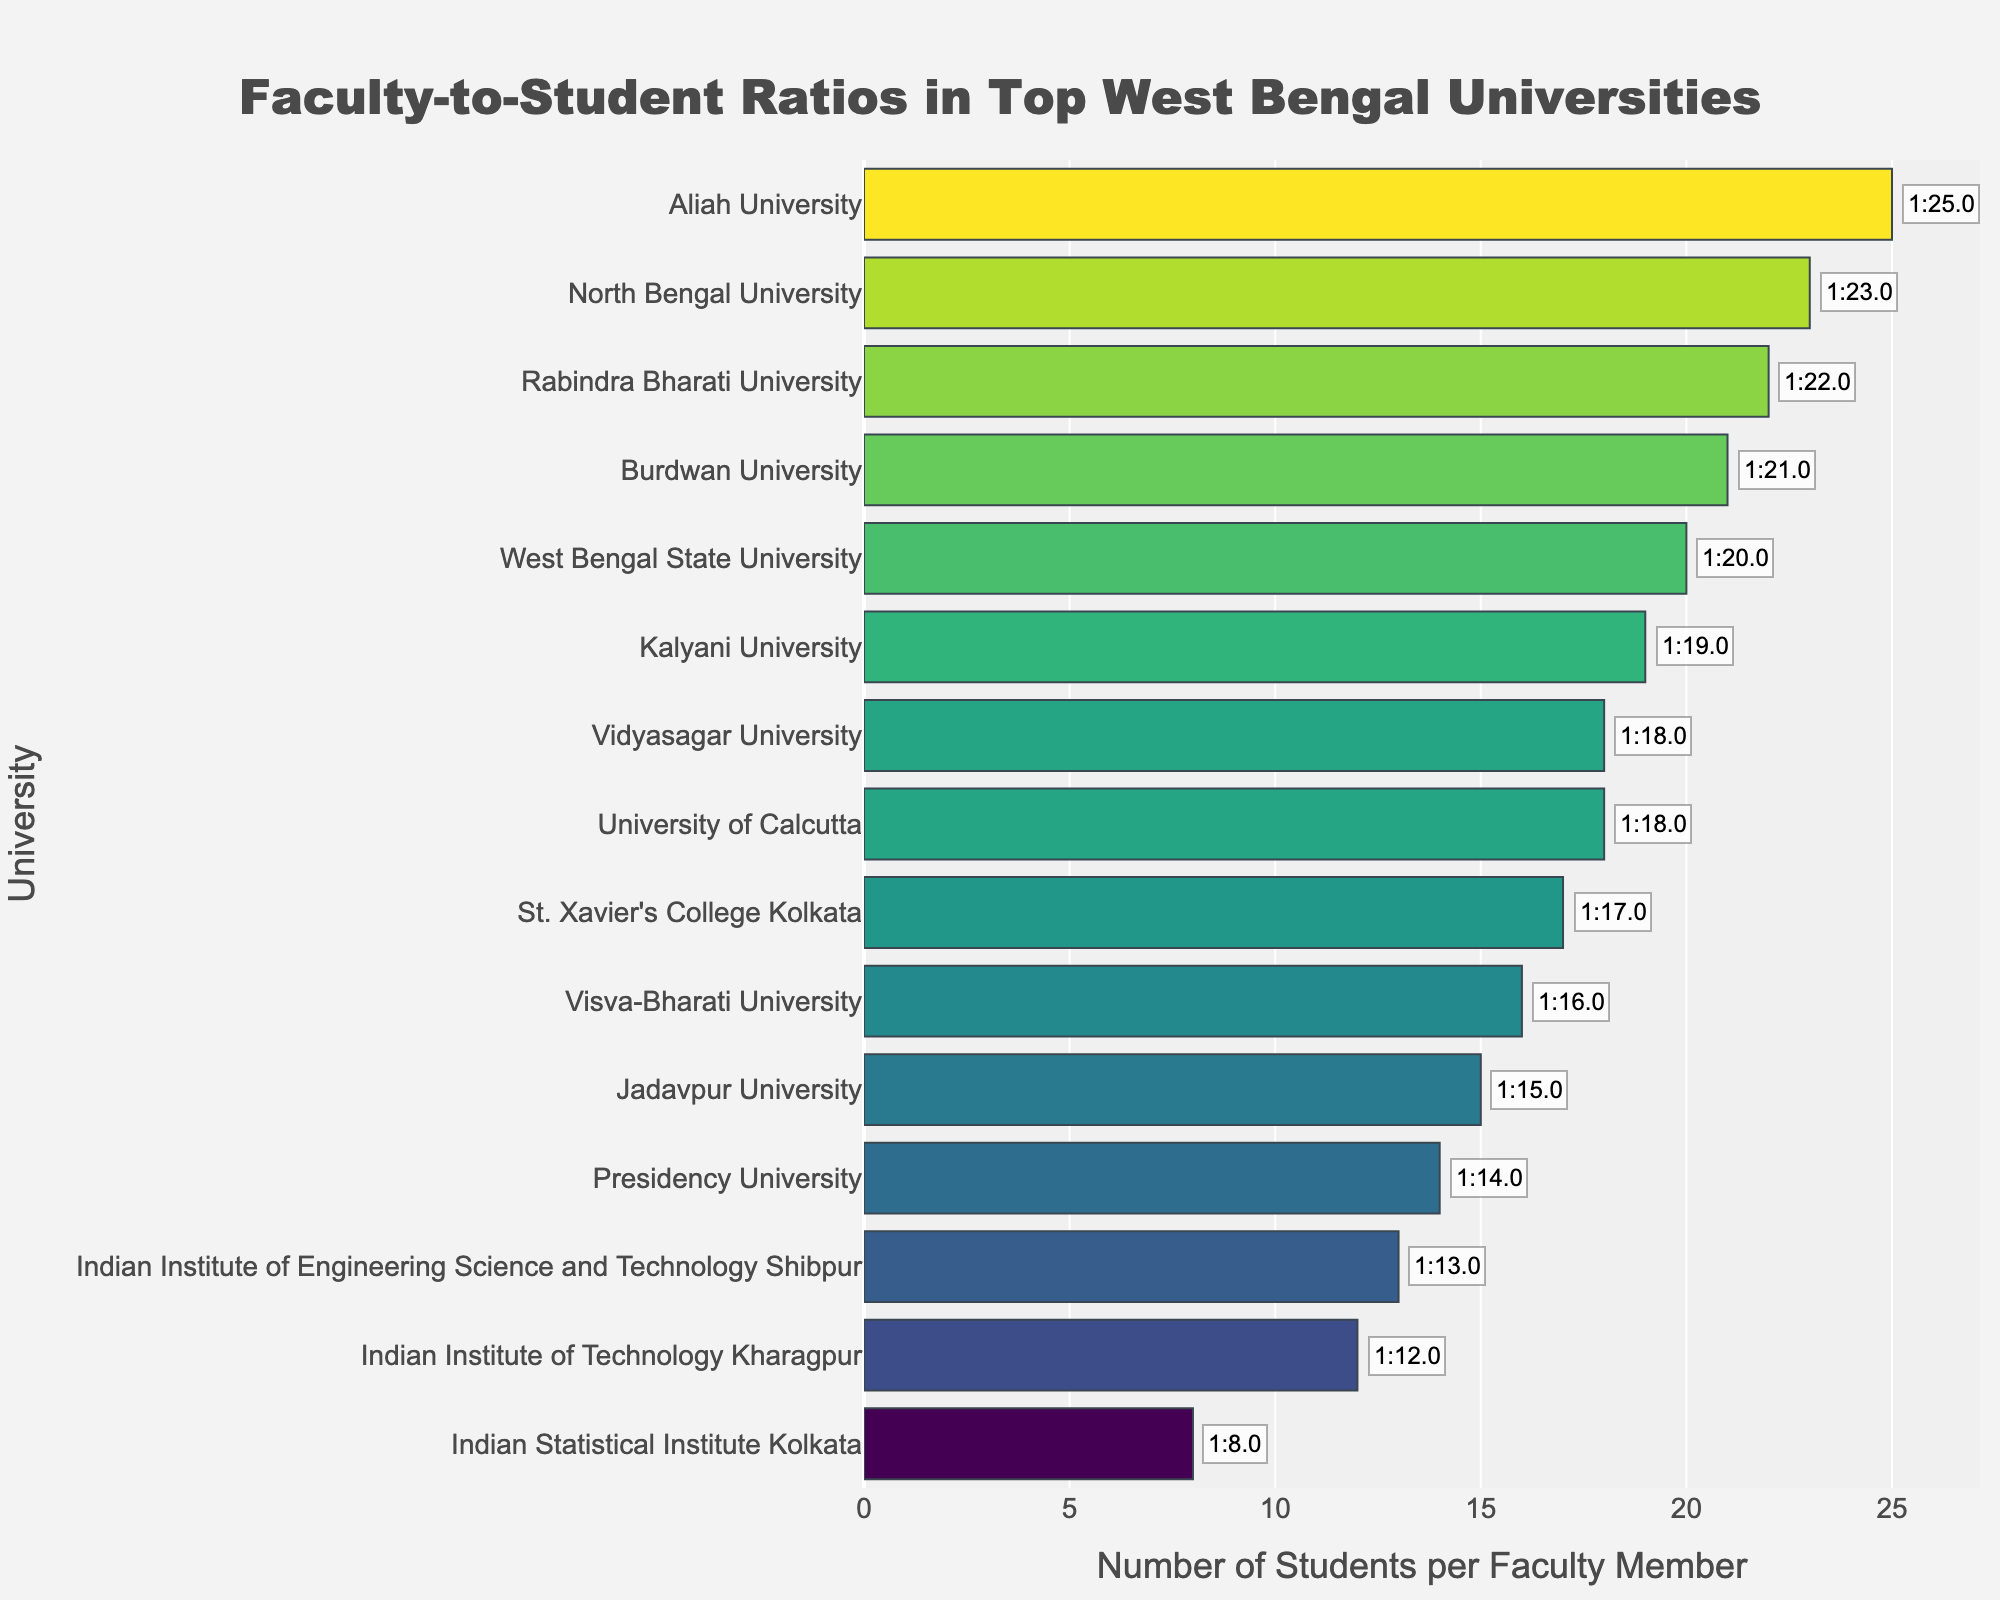Which university has the highest faculty-to-student ratio? By examining the horizontal bars, we see that Aliah University has the longest bar, indicating the highest ratio.
Answer: Aliah University Which university has the lowest faculty-to-student ratio? By examining the horizontal bars, we see that Indian Statistical Institute Kolkata has the shortest bar, indicating the lowest ratio.
Answer: Indian Statistical Institute Kolkata How does the faculty-to-student ratio of Jadavpur University compare to Presidency University? The bar for Jadavpur University is slightly longer than that of Presidency University. This indicates that Jadavpur University has a slightly higher faculty-to-student ratio.
Answer: Jadavpur University has a higher ratio What is the average faculty-to-student ratio of all universities listed? Sum the ratios: 15+18+12+8+14+16+20+22+17+19+21+23+18+13+25 = 261. There are 15 universities, so the average is 261/15.
Answer: 17.4 How many universities have a faculty-to-student ratio greater than 1:20? By counting the bars that extend beyond the value of 20 on the x-axis, we find that three universities exceed this ratio.
Answer: 3 What is the difference in faculty-to-student ratios between Indian Institute of Technology Kharagpur and Visva-Bharati University? IIT Kharagpur has a ratio of 12, and Visva-Bharati University has a ratio of 16. The difference is 16 - 12.
Answer: 4 Identify the university with a faculty-to-student ratio closest to 1:15. Comparing the ratios to see which one is closest to 15, we see Jadavpur University exactly matches 15.
Answer: Jadavpur University What is the overall trend in faculty-to-student ratios among the universities? Observing the color gradient and bar lengths, there's a mix of ratios with no significant clustering, but Aliah University has the highest, and Indian Statistical Institute Kolkata has the lowest. Ratios range from as low as 8 to as high as 25.
Answer: Diverse range Which universities have a faculty-to-student ratio between 1:15 and 1:18? Identifying the bars with values within this range, Jadavpur University, University of Calcutta, Presidency University, Visva-Bharati University, St. Xavier's College Kolkata, and Vidyasagar University fall in this range.
Answer: Jadavpur University, University of Calcutta, Presidency University, Visva-Bharati University, St. Xavier's College Kolkata, Vidyasagar University What percentage of universities have a faculty-to-student ratio of 1:20 or higher? There are 5 universities (West Bengal State University, Rabindra Bharati University, Burdwan University, North Bengal University, and Aliah University) out of 15 total. The percentage is (5/15)*100.
Answer: 33.3% 